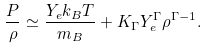<formula> <loc_0><loc_0><loc_500><loc_500>\frac { P } { \rho } \simeq \frac { Y _ { e } k _ { B } T } { m _ { B } } + K _ { \Gamma } Y _ { e } ^ { \Gamma } \rho ^ { \Gamma - 1 } .</formula> 